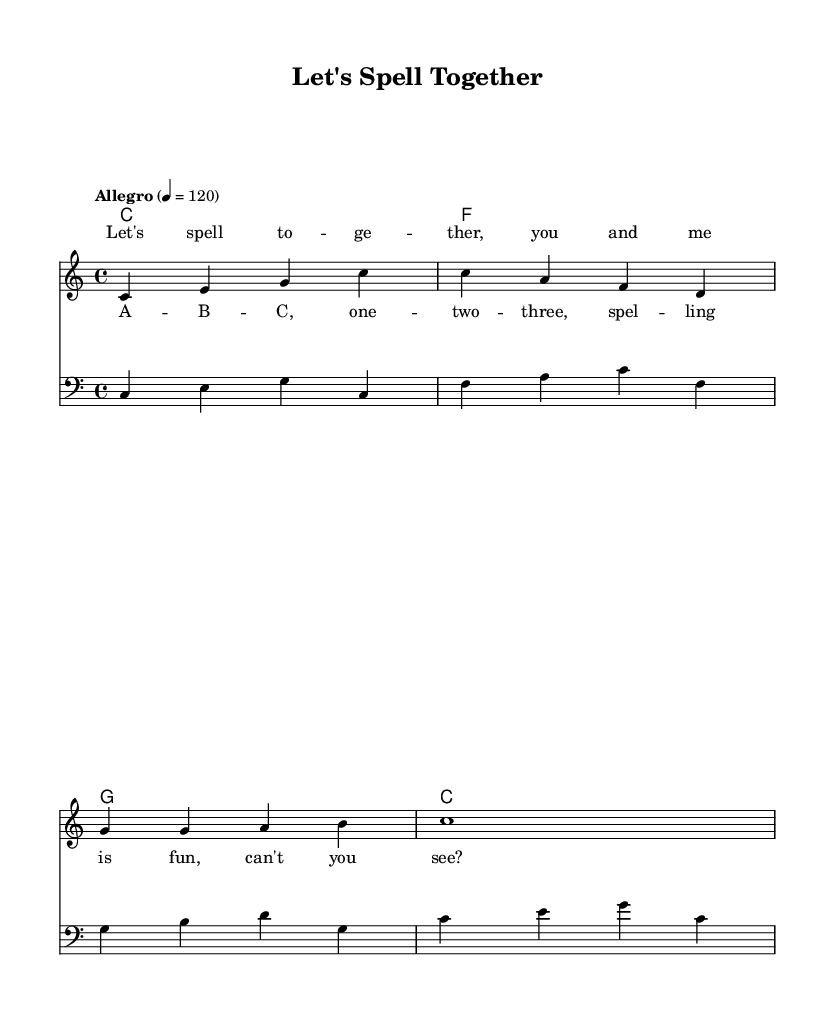What is the key signature of this music? The key signature is indicated by the "c" in the header and shows that there are no sharps or flats in the music, which defines C major.
Answer: C major What is the time signature of the music? The time signature is shown directly in the composition details as "4/4," meaning there are four beats in each measure.
Answer: 4/4 What is the tempo marking of the piece? The tempo marking reads "Allegro" with a metronome indication of "4 = 120," suggesting a lively and fast-paced performance at 120 beats per minute.
Answer: Allegro How many measures are in the melody? The melody consists of four measures, which can be counted based on the grouping of notes and bars indicated in the sheet music.
Answer: Four What is the last note in the melody? The last note in the melody is indicated by the single note "c1," which signifies a whole note on the pitch C.
Answer: C How many chords are used in the harmony section? The harmony section contains four distinct chords: C, F, G, and back to C, which can be counted directly from the chord notation provided.
Answer: Four What is the main theme of the lyrics? The lyrics focus on spelling together, as indicated in both the verse and chorus, emphasizing a fun and interactive learning activity.
Answer: Spelling 